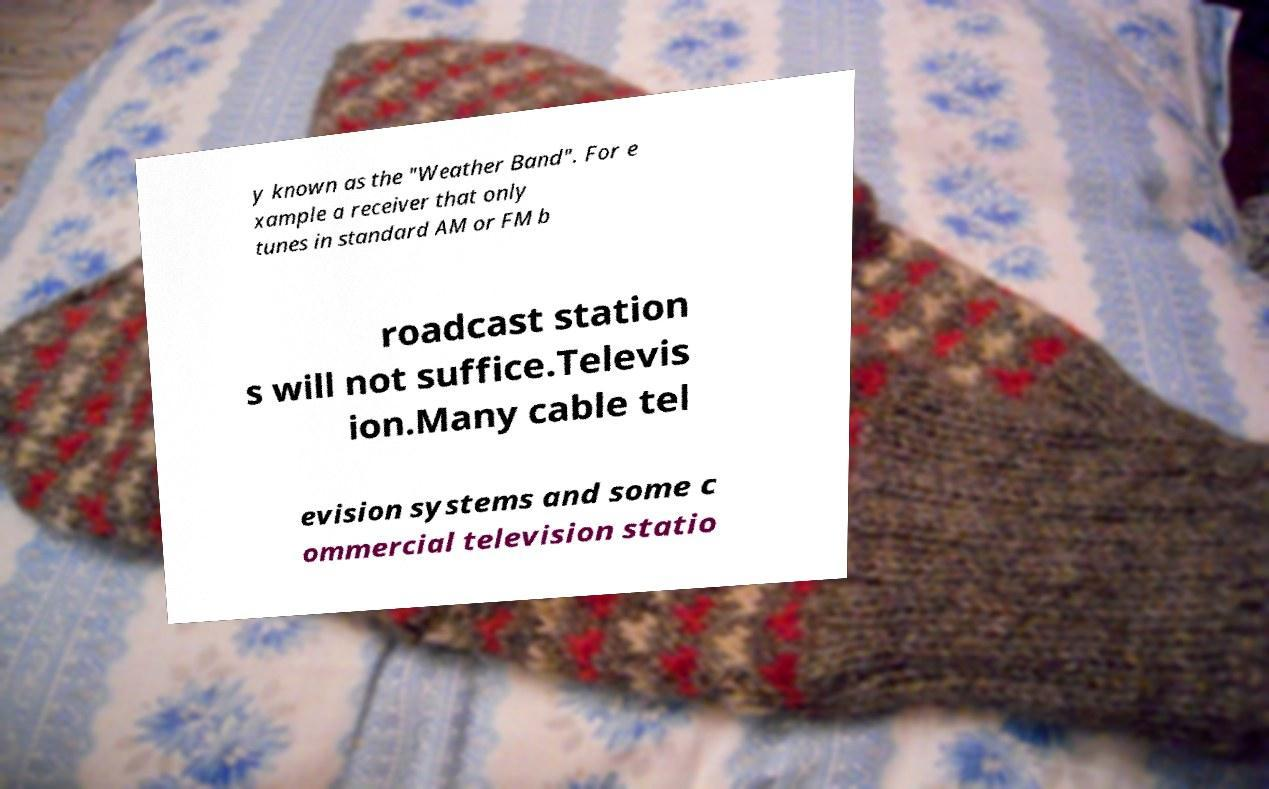Could you assist in decoding the text presented in this image and type it out clearly? y known as the "Weather Band". For e xample a receiver that only tunes in standard AM or FM b roadcast station s will not suffice.Televis ion.Many cable tel evision systems and some c ommercial television statio 